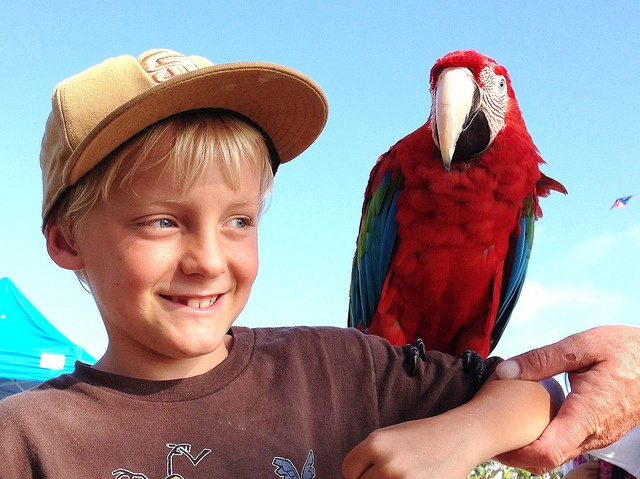Describe the objects in this image and their specific colors. I can see people in lightblue, maroon, brown, and tan tones, bird in lightblue, maroon, brown, black, and white tones, people in lightblue, salmon, brown, and tan tones, and kite in lightblue, lavender, violet, and pink tones in this image. 